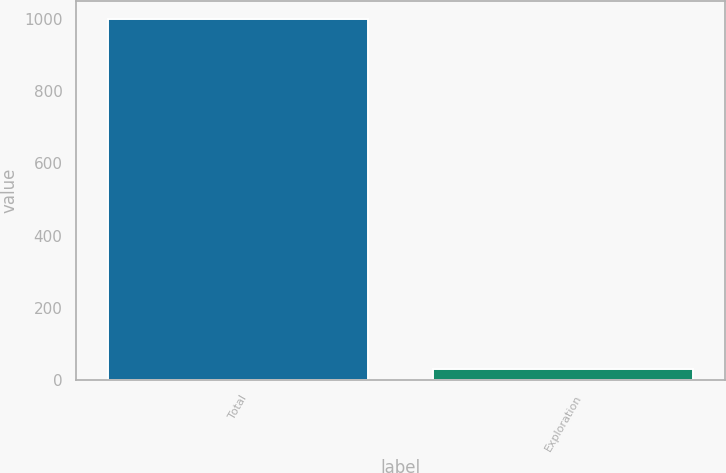Convert chart. <chart><loc_0><loc_0><loc_500><loc_500><bar_chart><fcel>Total<fcel>Exploration<nl><fcel>999<fcel>31<nl></chart> 